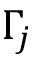<formula> <loc_0><loc_0><loc_500><loc_500>\Gamma _ { j }</formula> 